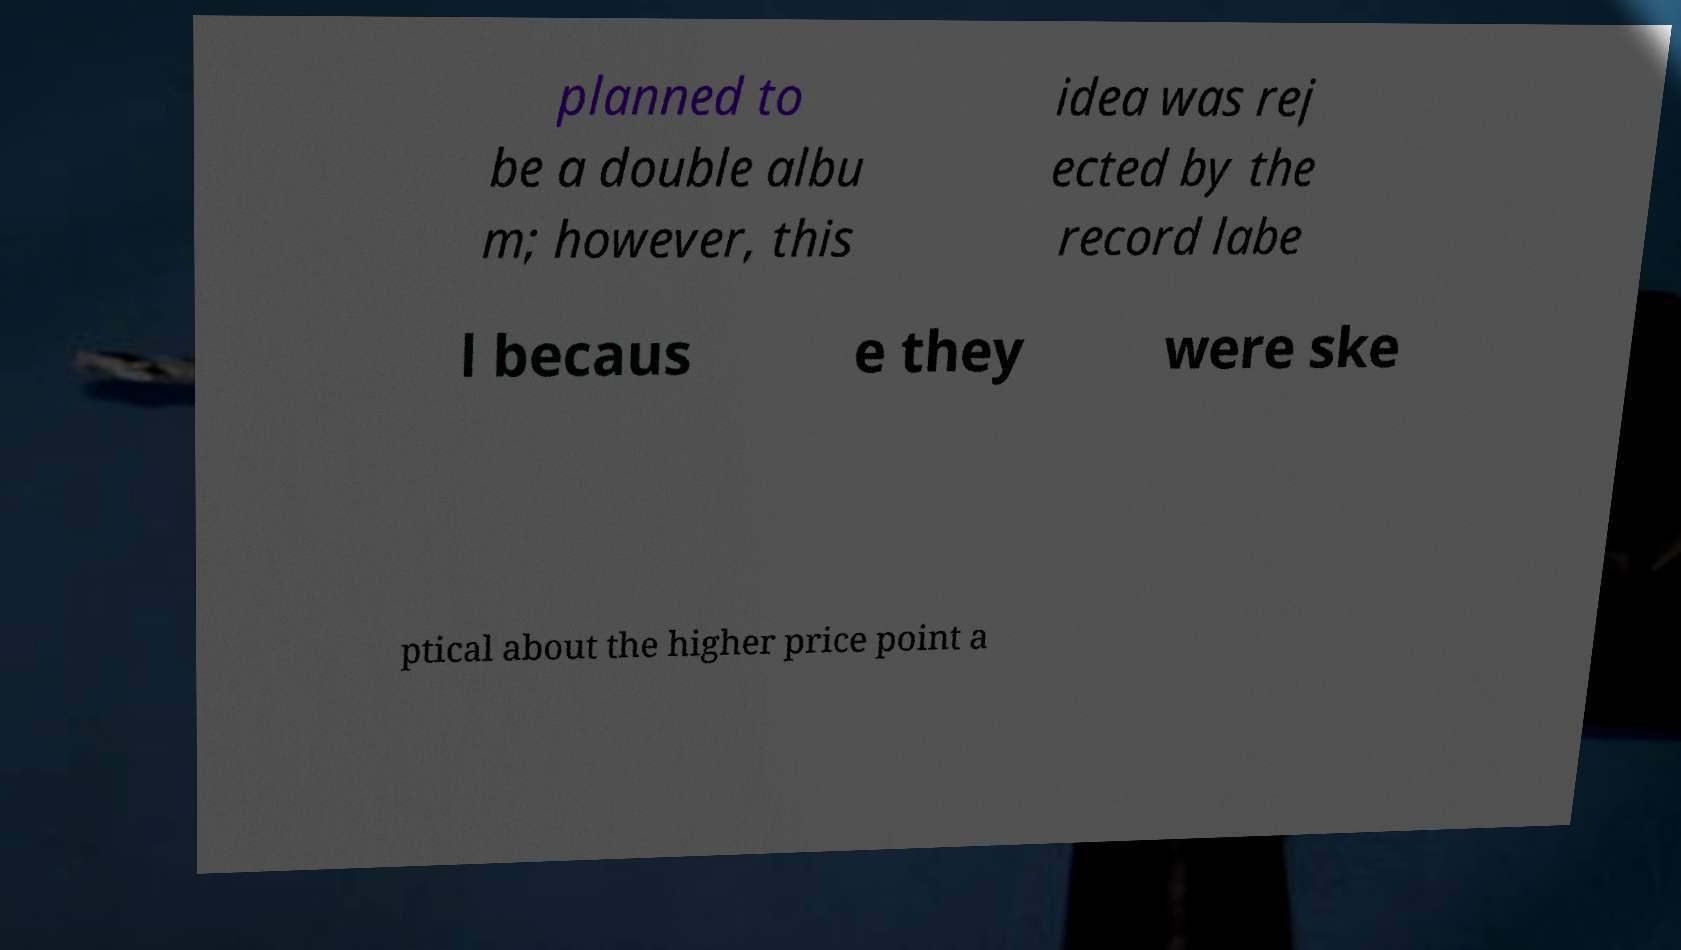Can you accurately transcribe the text from the provided image for me? planned to be a double albu m; however, this idea was rej ected by the record labe l becaus e they were ske ptical about the higher price point a 